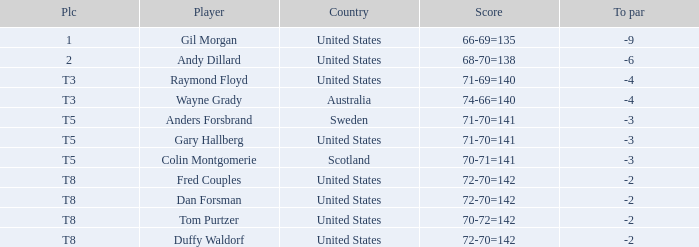What is Anders Forsbrand's Place? T5. 